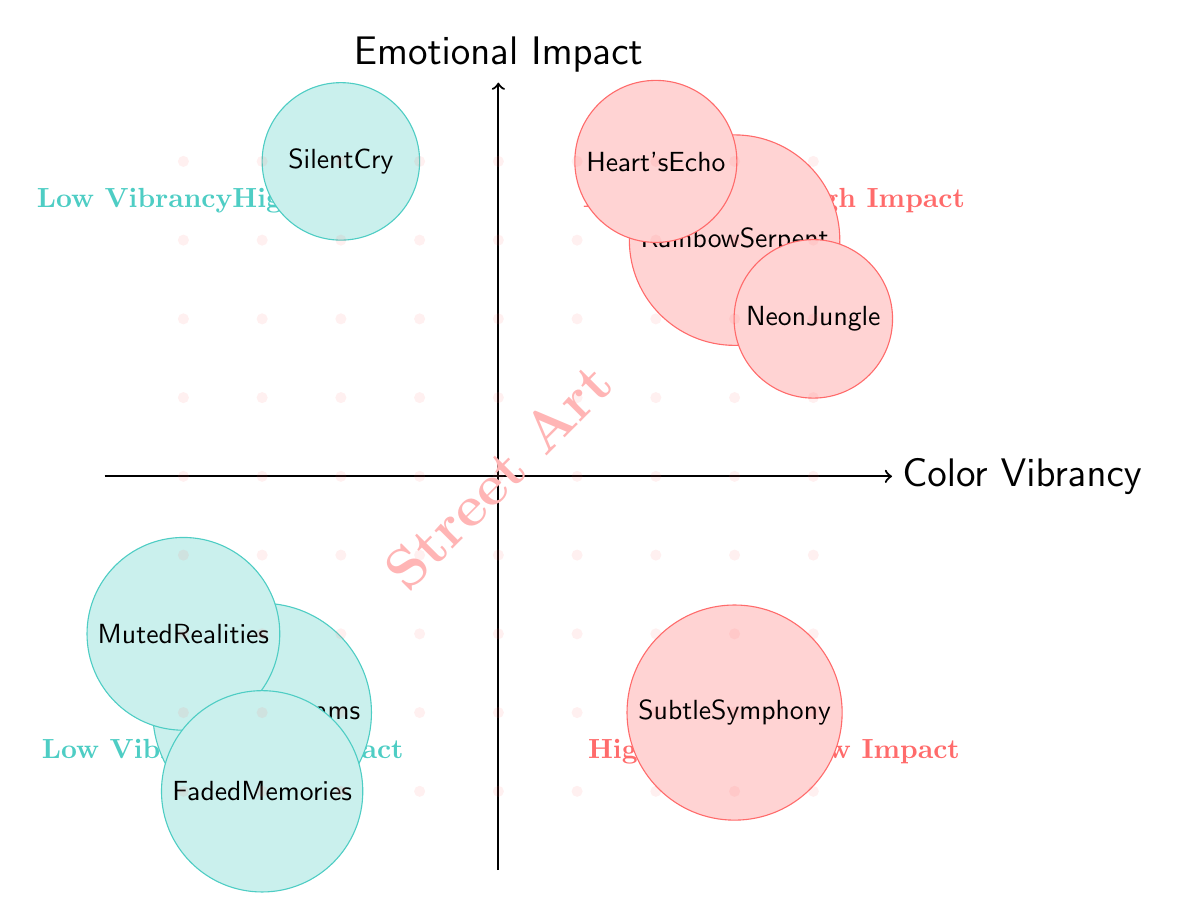What art piece is in the High Vibrancy, High Impact quadrant? In the High Vibrancy, High Impact quadrant, the art pieces are located at the coordinates (3,3) and (4,2). The art piece at (3,3) is "Rainbow Serpent."
Answer: Rainbow Serpent How many art pieces are in the Low Color Vibrancy quadrant? The Low Color Vibrancy quadrant contains the art pieces at coordinates (-3,-3) and (-4,-2), which means there are two art pieces in this quadrant.
Answer: 2 What emotional impact does "Neon Jungle" convey? "Neon Jungle" is located in the High Vibrancy, High Impact quadrant, and corresponds with the emotional impact described as "Excitement."
Answer: Excitement Which piece has a Low Color Vibrancy but a High Emotional Impact? The art piece located in the Low Vibrancy, High Impact quadrant corresponds to the emotional impact described as "Silent Cry," which is the only piece in this quadrant that fits the criteria.
Answer: Silent Cry What is the emotional impact of the art piece located at (-4,-2)? To find the impact, we refer to the quadrant of Low Vibrancy, Low Impact where this piece, "Muted Realities," is located, and it conveys "Melancholy."
Answer: Melancholy Which quadrant has the highest number of art pieces? Evaluating the quadrants, the High Vibrancy, High Impact quadrant has two art pieces ("Rainbow Serpent" and "Neon Jungle"), while the others have either one or two at most. Therefore, the quadrant with the most art pieces is High Vibrancy, High Impact.
Answer: High Vibrancy, High Impact What is the color vibrancy of "Faded Memories"? "Faded Memories" is located in the Low Vibrancy, Low Impact quadrant, which specifically indicates that its color vibrancy is "Low."
Answer: Low How many pieces convey High Emotional Impact? Reviewing the quadrants, there are two pieces that convey High Emotional Impact: "Heart's Echo" and "Silent Cry," which reside in the High Vibrancy, High Impact and Low Vibrancy, High Impact quadrants respectively.
Answer: 2 Which quadrant contains pieces with both High Vibrancy and Low Impact? The quadrant that contains pieces characterized by High Vibrancy and Low Impact is marked as "High Vibrancy Low Impact," which is identified by the coordinates nearest to (3,-3).
Answer: High Vibrancy Low Impact 